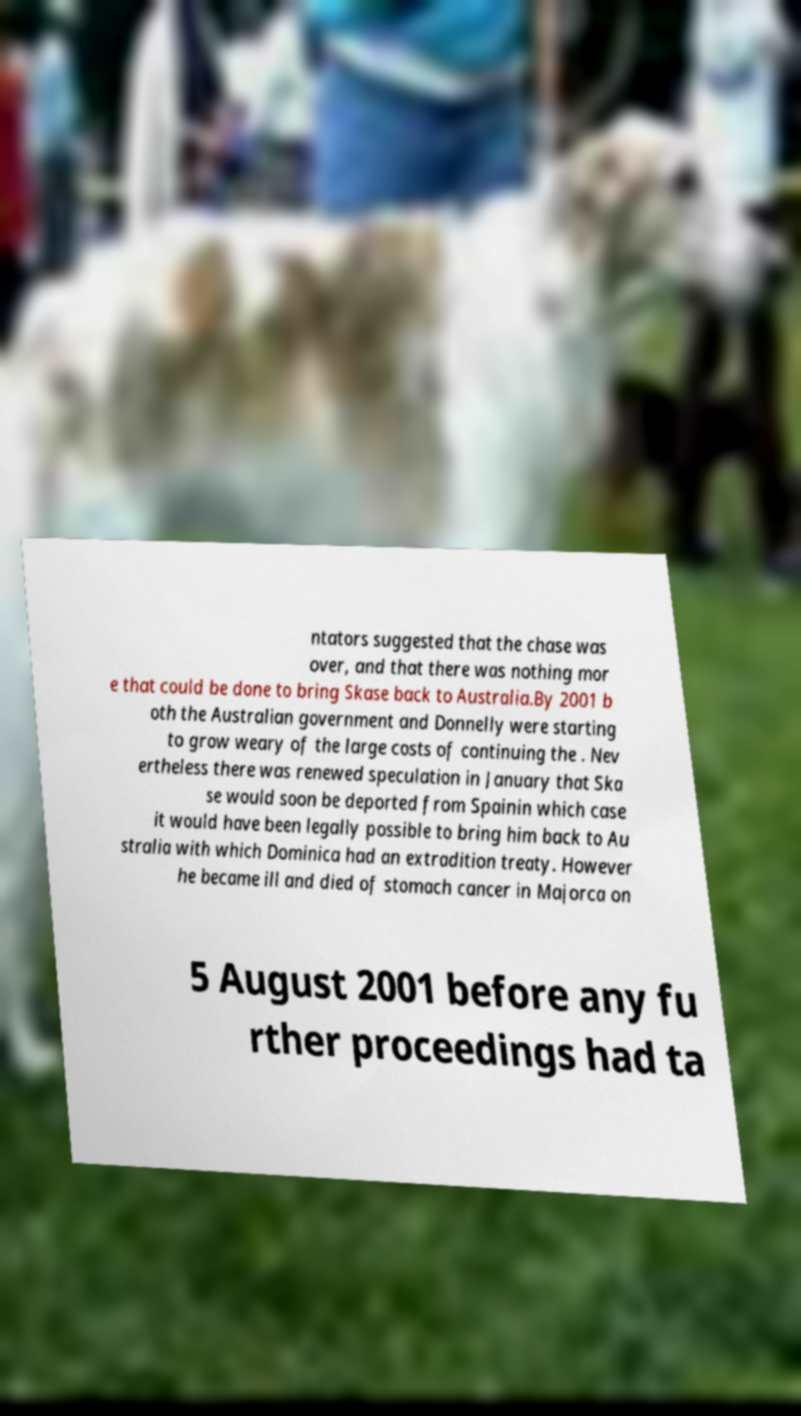Can you read and provide the text displayed in the image?This photo seems to have some interesting text. Can you extract and type it out for me? ntators suggested that the chase was over, and that there was nothing mor e that could be done to bring Skase back to Australia.By 2001 b oth the Australian government and Donnelly were starting to grow weary of the large costs of continuing the . Nev ertheless there was renewed speculation in January that Ska se would soon be deported from Spainin which case it would have been legally possible to bring him back to Au stralia with which Dominica had an extradition treaty. However he became ill and died of stomach cancer in Majorca on 5 August 2001 before any fu rther proceedings had ta 